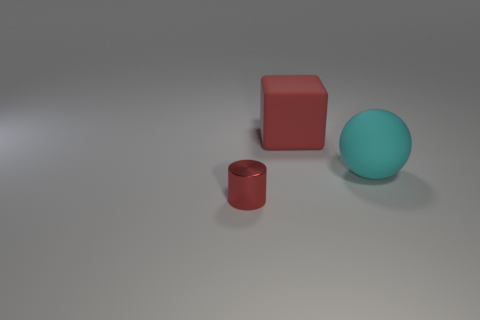There is a cube that is the same color as the cylinder; what size is it?
Give a very brief answer. Large. Is the number of tiny metallic cylinders in front of the big cyan matte sphere less than the number of things that are in front of the big block?
Provide a succinct answer. Yes. Is there any other thing that has the same size as the cylinder?
Give a very brief answer. No. The tiny red metal thing has what shape?
Provide a short and direct response. Cylinder. What is the material of the thing on the right side of the red matte cube?
Offer a very short reply. Rubber. What size is the thing on the right side of the matte thing to the left of the large thing right of the red matte thing?
Your answer should be very brief. Large. Does the red object behind the small red metal thing have the same material as the red thing in front of the cyan thing?
Give a very brief answer. No. What number of other objects are the same color as the matte cube?
Your answer should be compact. 1. What number of objects are either red things to the right of the red shiny cylinder or objects that are in front of the red cube?
Make the answer very short. 3. There is a red object on the right side of the object in front of the cyan rubber ball; how big is it?
Keep it short and to the point. Large. 